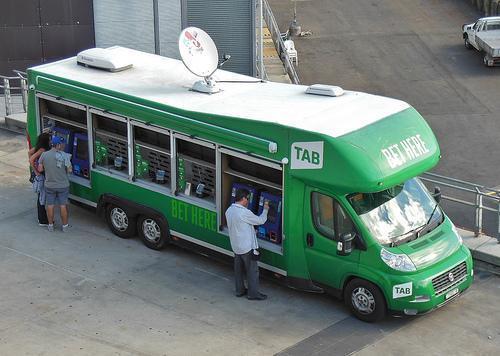How many peopl at the bus?
Give a very brief answer. 3. 